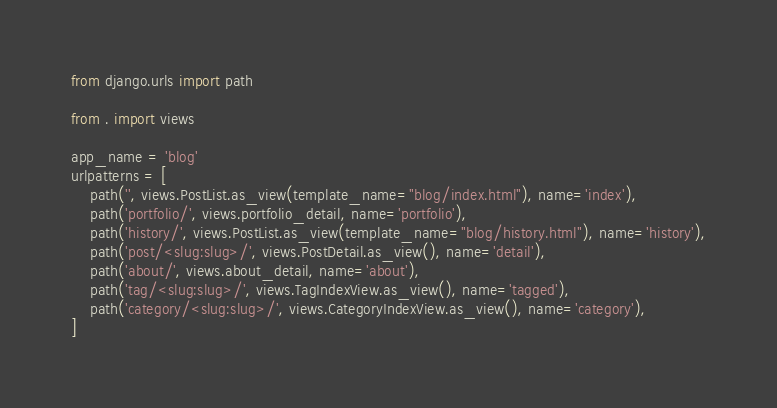Convert code to text. <code><loc_0><loc_0><loc_500><loc_500><_Python_>from django.urls import path

from . import views

app_name = 'blog'
urlpatterns = [
    path('', views.PostList.as_view(template_name="blog/index.html"), name='index'),
    path('portfolio/', views.portfolio_detail, name='portfolio'),
    path('history/', views.PostList.as_view(template_name="blog/history.html"), name='history'),
    path('post/<slug:slug>/', views.PostDetail.as_view(), name='detail'),
    path('about/', views.about_detail, name='about'),
    path('tag/<slug:slug>/', views.TagIndexView.as_view(), name='tagged'),
    path('category/<slug:slug>/', views.CategoryIndexView.as_view(), name='category'),
]
</code> 